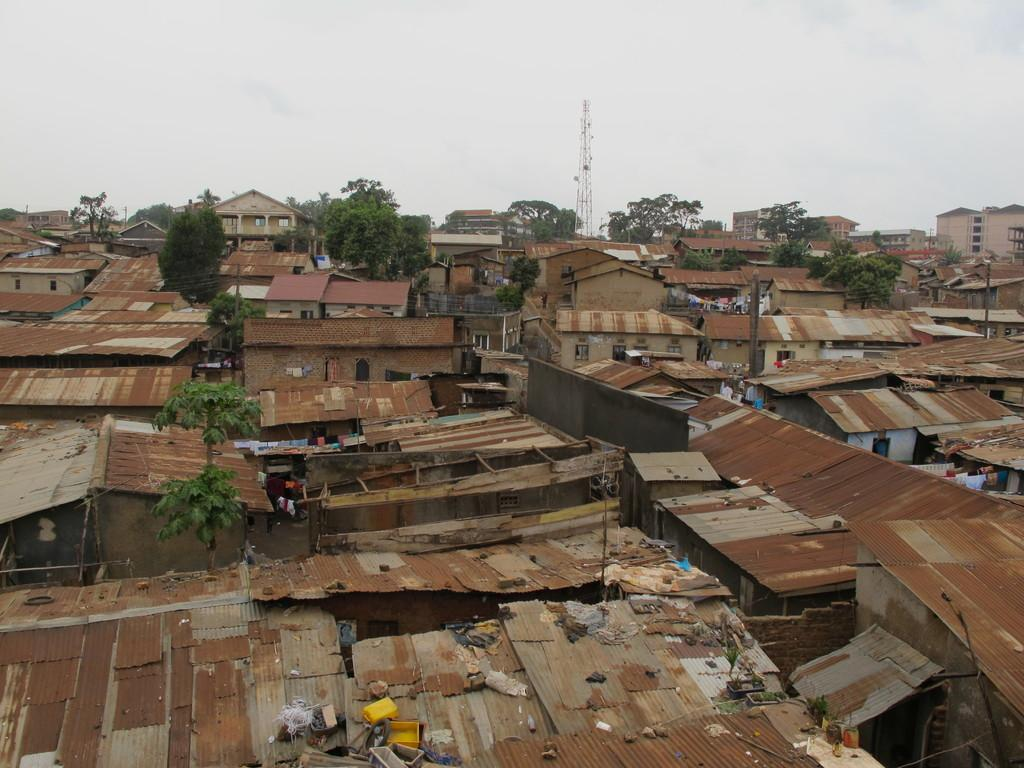What type of houses are shown in the image? The image shows smaller shut houses. How is the perspective of the image? The image shows a top view of the houses. What can be seen in the background of the image? There are trees and an electric tower visible in the background. What is visible in the sky in the image? The sky is visible in the image, and clouds are present. What type of ring can be seen on the toad's finger in the image? There is no toad or ring present in the image. What is the toad learning in the image? There is no toad or learning activity depicted in the image. 